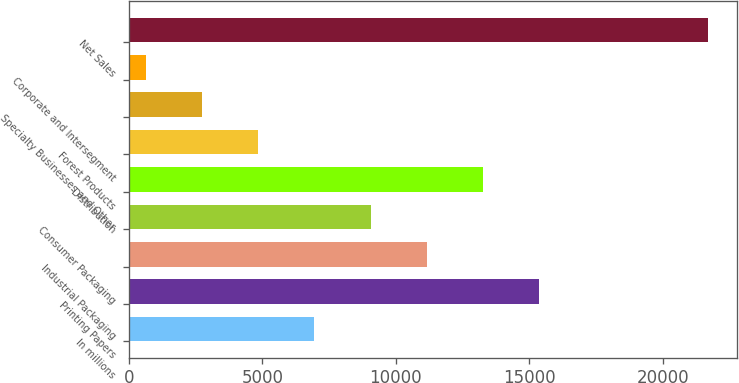<chart> <loc_0><loc_0><loc_500><loc_500><bar_chart><fcel>In millions<fcel>Printing Papers<fcel>Industrial Packaging<fcel>Consumer Packaging<fcel>Distribution<fcel>Forest Products<fcel>Specialty Businesses and Other<fcel>Corporate and Intersegment<fcel>Net Sales<nl><fcel>6951<fcel>15379<fcel>11165<fcel>9058<fcel>13272<fcel>4844<fcel>2737<fcel>630<fcel>21700<nl></chart> 